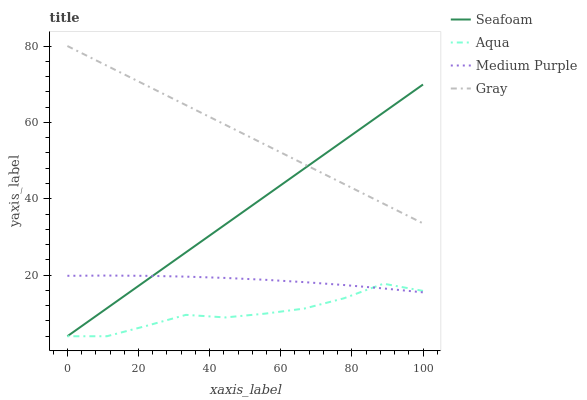Does Aqua have the minimum area under the curve?
Answer yes or no. Yes. Does Gray have the maximum area under the curve?
Answer yes or no. Yes. Does Gray have the minimum area under the curve?
Answer yes or no. No. Does Aqua have the maximum area under the curve?
Answer yes or no. No. Is Seafoam the smoothest?
Answer yes or no. Yes. Is Aqua the roughest?
Answer yes or no. Yes. Is Gray the smoothest?
Answer yes or no. No. Is Gray the roughest?
Answer yes or no. No. Does Aqua have the lowest value?
Answer yes or no. Yes. Does Gray have the lowest value?
Answer yes or no. No. Does Gray have the highest value?
Answer yes or no. Yes. Does Aqua have the highest value?
Answer yes or no. No. Is Aqua less than Gray?
Answer yes or no. Yes. Is Gray greater than Medium Purple?
Answer yes or no. Yes. Does Aqua intersect Medium Purple?
Answer yes or no. Yes. Is Aqua less than Medium Purple?
Answer yes or no. No. Is Aqua greater than Medium Purple?
Answer yes or no. No. Does Aqua intersect Gray?
Answer yes or no. No. 